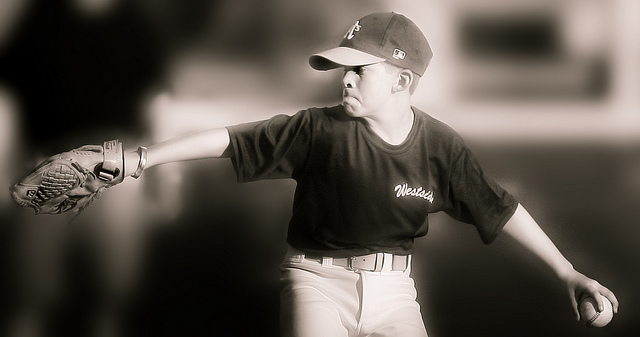Identify and read out the text in this image. Western 